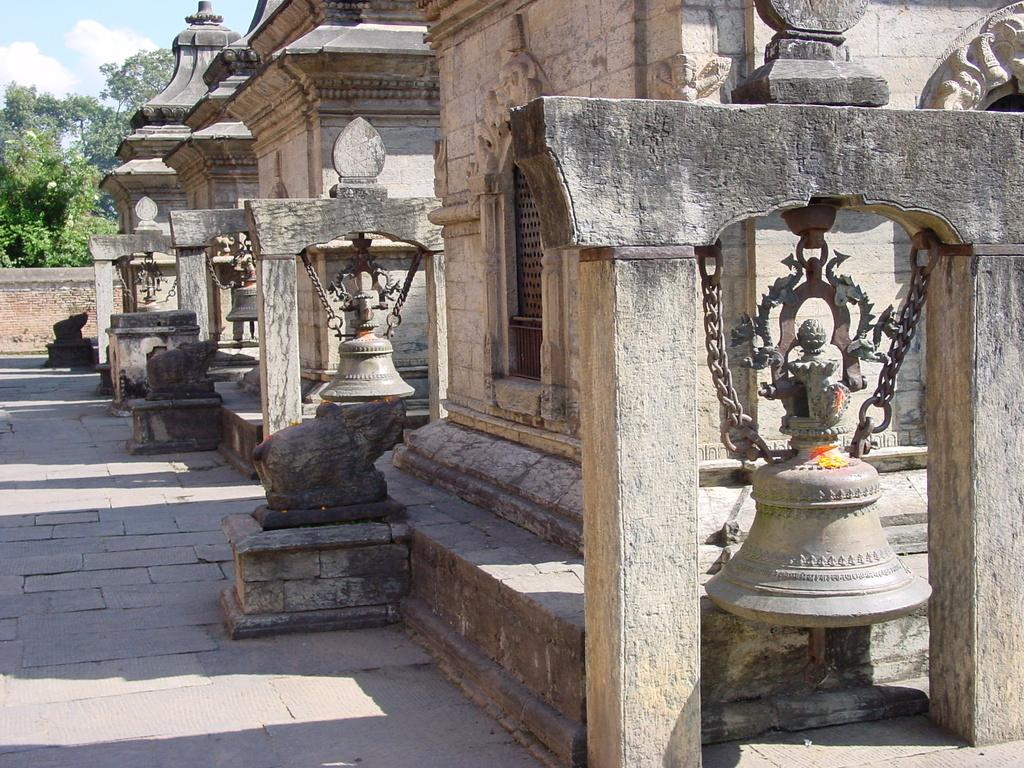What type of structure is featured in the picture? There is an ancient building in the picture. What can be seen near the ancient building? There are beers and a path in front of the building. What is visible in the background of the picture? There are trees and the sky in the background of the picture. What type of bun is being used to hold the credit in the image? There is no bun or credit present in the image; it features an ancient building, beers, a path, trees, and the sky. 